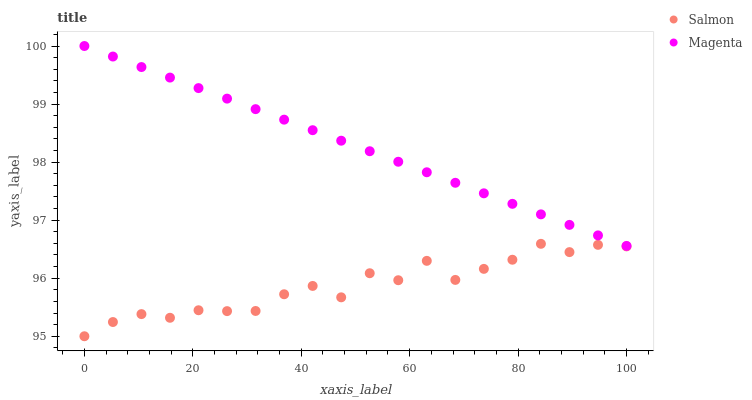Does Salmon have the minimum area under the curve?
Answer yes or no. Yes. Does Magenta have the maximum area under the curve?
Answer yes or no. Yes. Does Salmon have the maximum area under the curve?
Answer yes or no. No. Is Magenta the smoothest?
Answer yes or no. Yes. Is Salmon the roughest?
Answer yes or no. Yes. Is Salmon the smoothest?
Answer yes or no. No. Does Salmon have the lowest value?
Answer yes or no. Yes. Does Magenta have the highest value?
Answer yes or no. Yes. Does Salmon have the highest value?
Answer yes or no. No. Is Salmon less than Magenta?
Answer yes or no. Yes. Is Magenta greater than Salmon?
Answer yes or no. Yes. Does Salmon intersect Magenta?
Answer yes or no. No. 